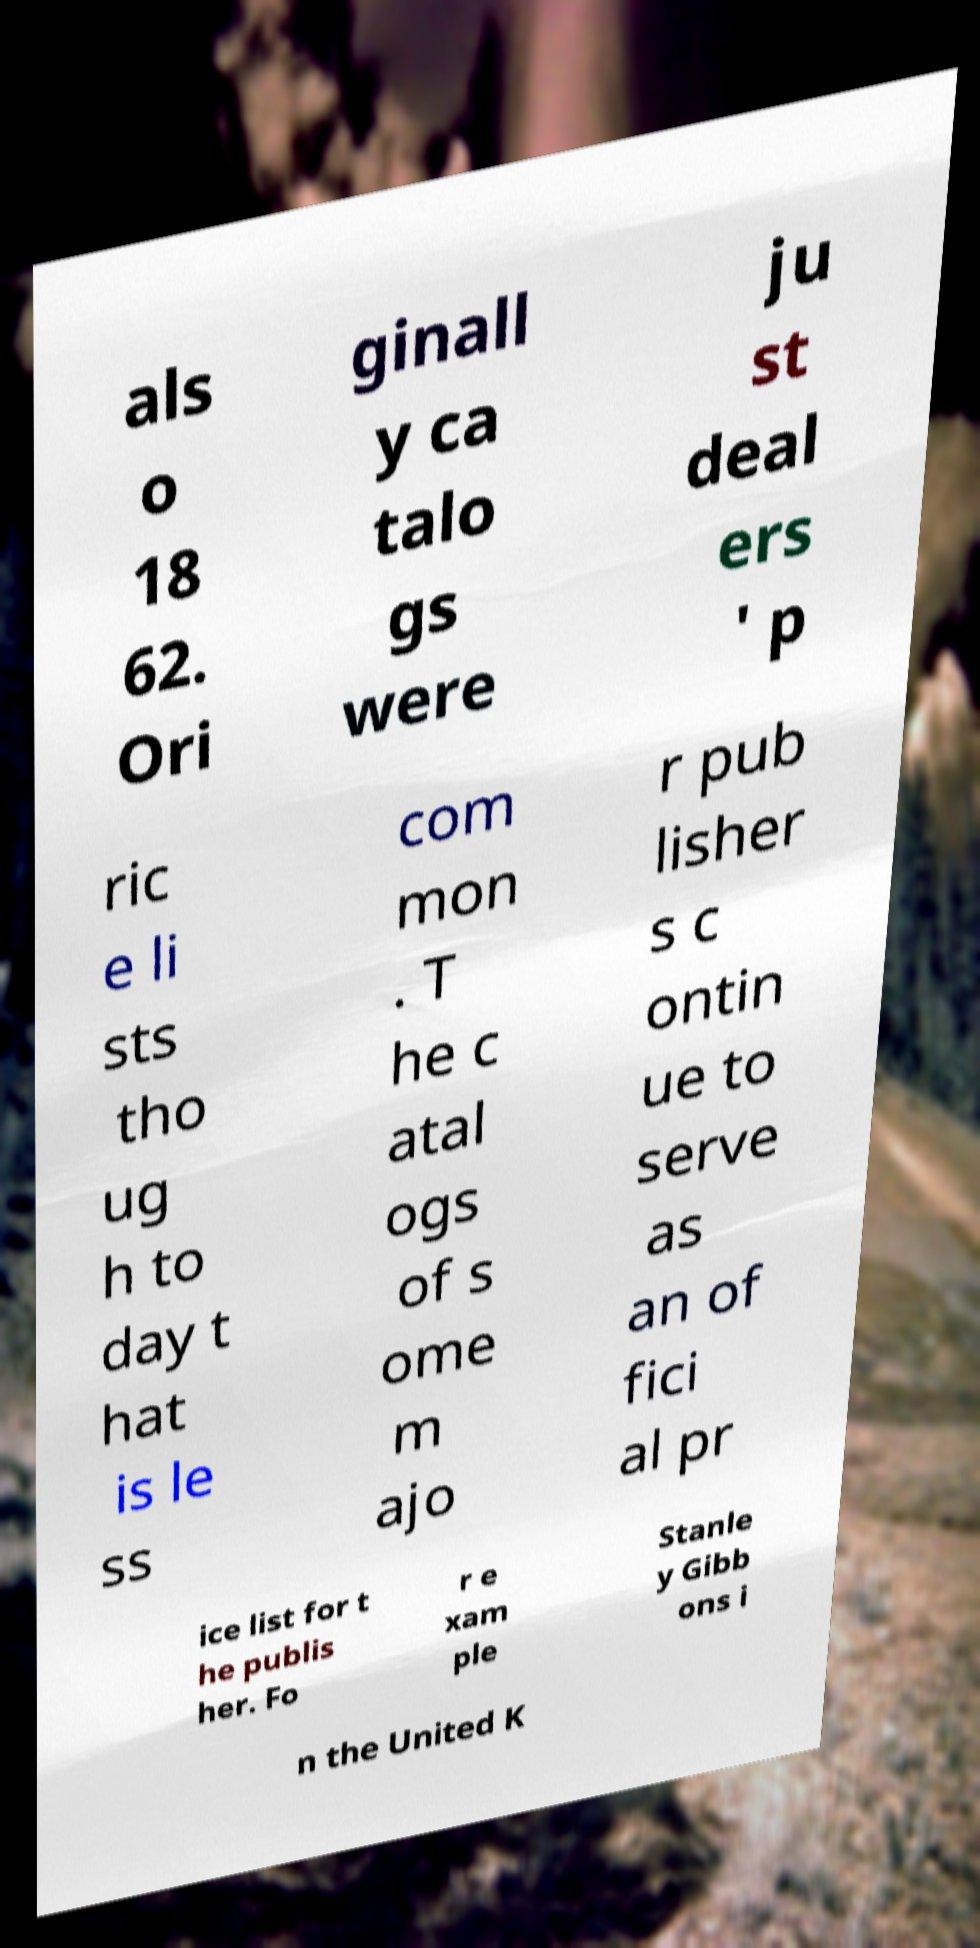I need the written content from this picture converted into text. Can you do that? als o 18 62. Ori ginall y ca talo gs were ju st deal ers ' p ric e li sts tho ug h to day t hat is le ss com mon . T he c atal ogs of s ome m ajo r pub lisher s c ontin ue to serve as an of fici al pr ice list for t he publis her. Fo r e xam ple Stanle y Gibb ons i n the United K 